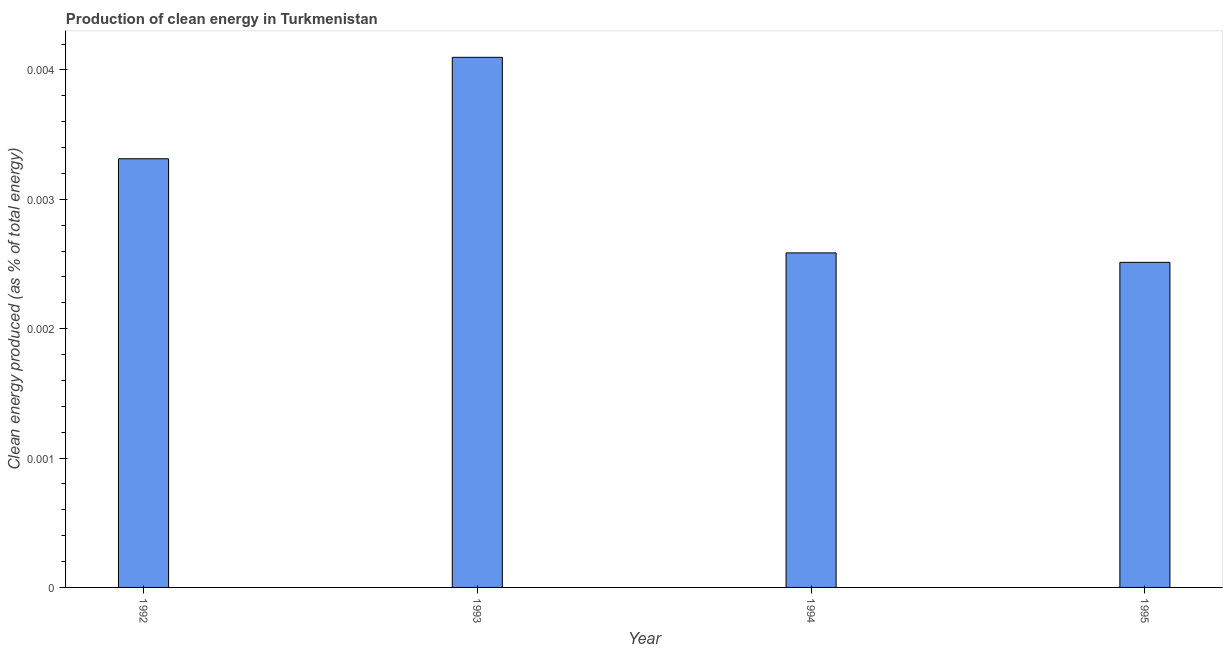What is the title of the graph?
Provide a short and direct response. Production of clean energy in Turkmenistan. What is the label or title of the Y-axis?
Offer a very short reply. Clean energy produced (as % of total energy). What is the production of clean energy in 1993?
Offer a very short reply. 0. Across all years, what is the maximum production of clean energy?
Your answer should be very brief. 0. Across all years, what is the minimum production of clean energy?
Make the answer very short. 0. In which year was the production of clean energy maximum?
Provide a succinct answer. 1993. In which year was the production of clean energy minimum?
Your answer should be compact. 1995. What is the sum of the production of clean energy?
Make the answer very short. 0.01. What is the average production of clean energy per year?
Your answer should be compact. 0. What is the median production of clean energy?
Give a very brief answer. 0. Do a majority of the years between 1995 and 1994 (inclusive) have production of clean energy greater than 0.002 %?
Keep it short and to the point. No. What is the ratio of the production of clean energy in 1993 to that in 1995?
Offer a very short reply. 1.63. What is the difference between the highest and the second highest production of clean energy?
Provide a short and direct response. 0. What is the difference between the highest and the lowest production of clean energy?
Offer a terse response. 0. How many bars are there?
Keep it short and to the point. 4. How many years are there in the graph?
Your answer should be compact. 4. What is the difference between two consecutive major ticks on the Y-axis?
Give a very brief answer. 0. Are the values on the major ticks of Y-axis written in scientific E-notation?
Your response must be concise. No. What is the Clean energy produced (as % of total energy) of 1992?
Your response must be concise. 0. What is the Clean energy produced (as % of total energy) in 1993?
Your answer should be compact. 0. What is the Clean energy produced (as % of total energy) in 1994?
Offer a very short reply. 0. What is the Clean energy produced (as % of total energy) in 1995?
Your answer should be very brief. 0. What is the difference between the Clean energy produced (as % of total energy) in 1992 and 1993?
Ensure brevity in your answer.  -0. What is the difference between the Clean energy produced (as % of total energy) in 1992 and 1994?
Ensure brevity in your answer.  0. What is the difference between the Clean energy produced (as % of total energy) in 1992 and 1995?
Provide a short and direct response. 0. What is the difference between the Clean energy produced (as % of total energy) in 1993 and 1994?
Keep it short and to the point. 0. What is the difference between the Clean energy produced (as % of total energy) in 1993 and 1995?
Your answer should be very brief. 0. What is the difference between the Clean energy produced (as % of total energy) in 1994 and 1995?
Your answer should be compact. 7e-5. What is the ratio of the Clean energy produced (as % of total energy) in 1992 to that in 1993?
Give a very brief answer. 0.81. What is the ratio of the Clean energy produced (as % of total energy) in 1992 to that in 1994?
Give a very brief answer. 1.28. What is the ratio of the Clean energy produced (as % of total energy) in 1992 to that in 1995?
Give a very brief answer. 1.32. What is the ratio of the Clean energy produced (as % of total energy) in 1993 to that in 1994?
Your response must be concise. 1.58. What is the ratio of the Clean energy produced (as % of total energy) in 1993 to that in 1995?
Your response must be concise. 1.63. 